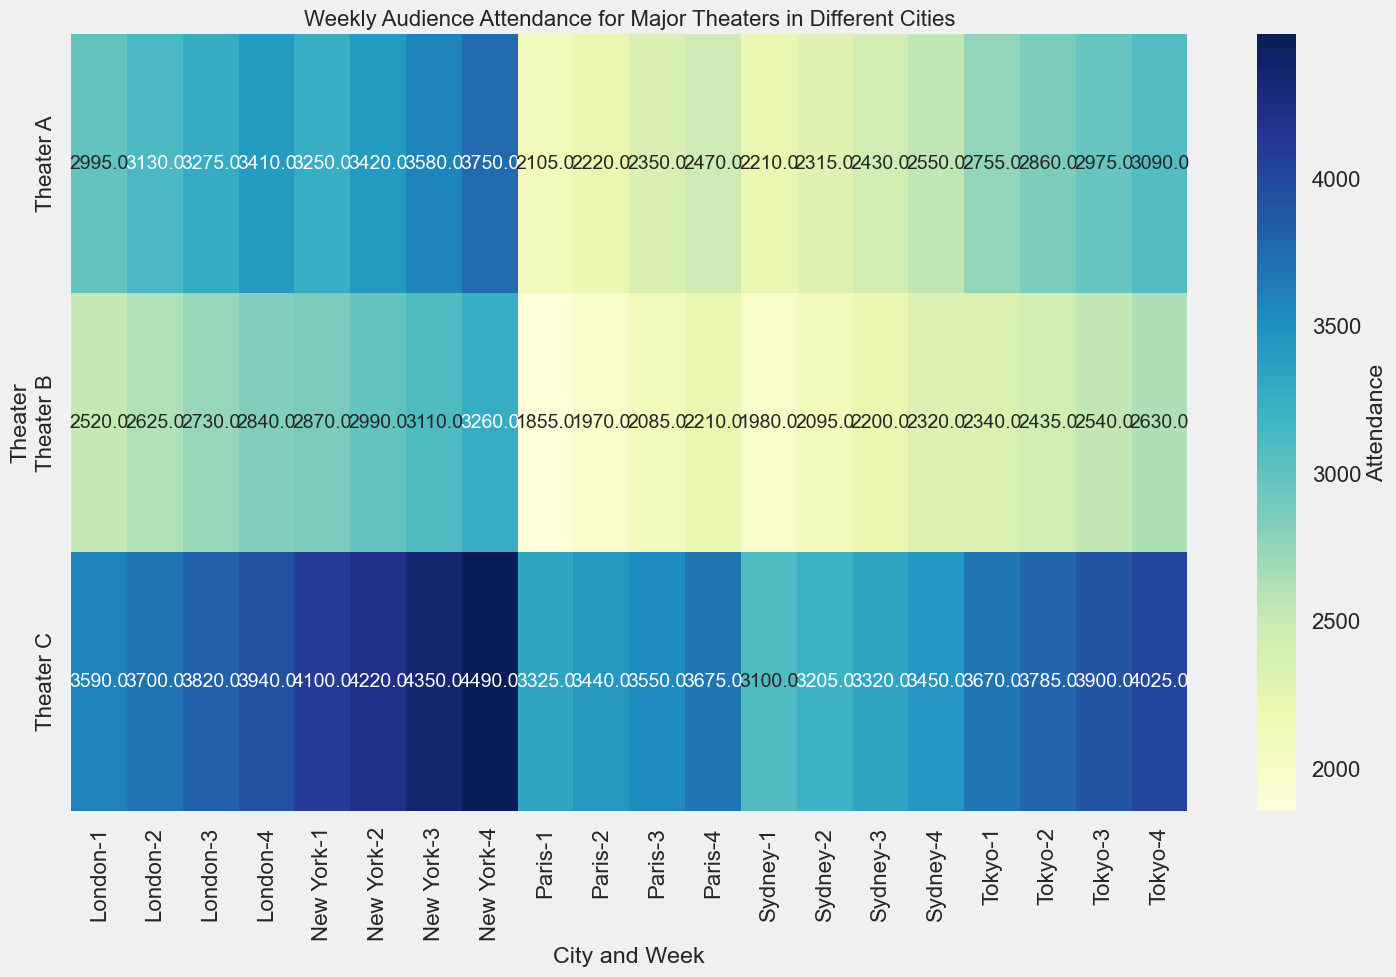Which city-theater-week combination has the highest attendance? Look at the heatmap and identify the cell with the highest value. The highest value in the matrix correlates with New York, Theater C, Week 4 at 4490.0 attendance.
Answer: New York, Theater C, Week 4 Which city-theater combination generally has the lowest attendance across all weeks? Observe the colors representing low attendance levels in the heatmap. Sydney, Theater B generally has the lowest values, as indicated by the lighter shades.
Answer: Sydney, Theater B What is the average weekly attendance for Theater A in New York? Sum the attendance for Theater A in New York across all weeks and then divide by the number of weeks (4). For New York, Theater A: (3250 + 3420 + 3580 + 3750) = 14000. The average is 14000 / 4 = 3500.0
Answer: 3500.0 How does the attendance of Theater B in London compare to Theater B in Tokyo during Week 2? Check the attendance values for Theater B in London and Tokyo for Week 2. In London, Theater B has 2625, and in Tokyo, Theater B has 2435. Since 2625 is greater than 2435, attendance is higher in London.
Answer: London's attendance is higher What is the total attendance for Theater C across all cities during Week 3? Sum the attendance for Theater C across New York, London, Sydney, Tokyo, and Paris during Week 3. The total is 4350 + 3820 + 3320 + 3900 + 3550 = 18940.0
Answer: 18940.0 Which city saw the highest increase in attendance from Week 1 to Week 4 for Theater A? Calculate the difference in attendance from Week 1 to Week 4 for Theater A in each city and find the highest increase. For New York: 3750 - 3250 = 500. For London: 3410 - 2995 = 415. For Sydney: 2550 - 2210 = 340. For Tokyo: 3090 - 2755 = 335. For Paris: 2470 - 2105 = 365. New York has the highest increase with 500.
Answer: New York Is there any week where all theaters in Tokyo had lower attendance than any week in New York? Compare the attendance values for all theaters in Tokyo with all weeks in New York. Find if there is at least one week where all Tokyo values are lower than any New York values. The lowest value in New York is 2870 for Theater B, Week 1, higher than the highest in Tokyo, 4025.
Answer: No Which Theater in Sydney showed the most significant weekly increase in attendance? Calculate the weekly differences for attendance in Sydney theaters and find the highest increase. For Theater A: (2315-2210), (2430-2315), (2550-2430) = 105, 115, 120. For Theater B: (2095-1980), (2200-2095), (2320-2200) = 115, 105, 120. For Theater C: (3205-3100), (3320-3205), (3450-3320) = 105, 115, 130. Theater C shows the highest increase 130.
Answer: Theater C Does Theater C consistently have higher attendance than Theater B across all cities? Compare the values of Theater C and Theater B across all cities in the heatmap. Theater C consistently has higher attendance in every city and week compared to Theater B, as seen in the heatmap.
Answer: Yes What is the mean attendance for Theater C in Paris over the four weeks? Sum the attendance for Theater C in Paris across all weeks and divide by 4. For Paris, Theater C: (3325 + 3440 + 3550 + 3675) = 13990. The mean is 13990 / 4 = 3497.5
Answer: 3497.5 